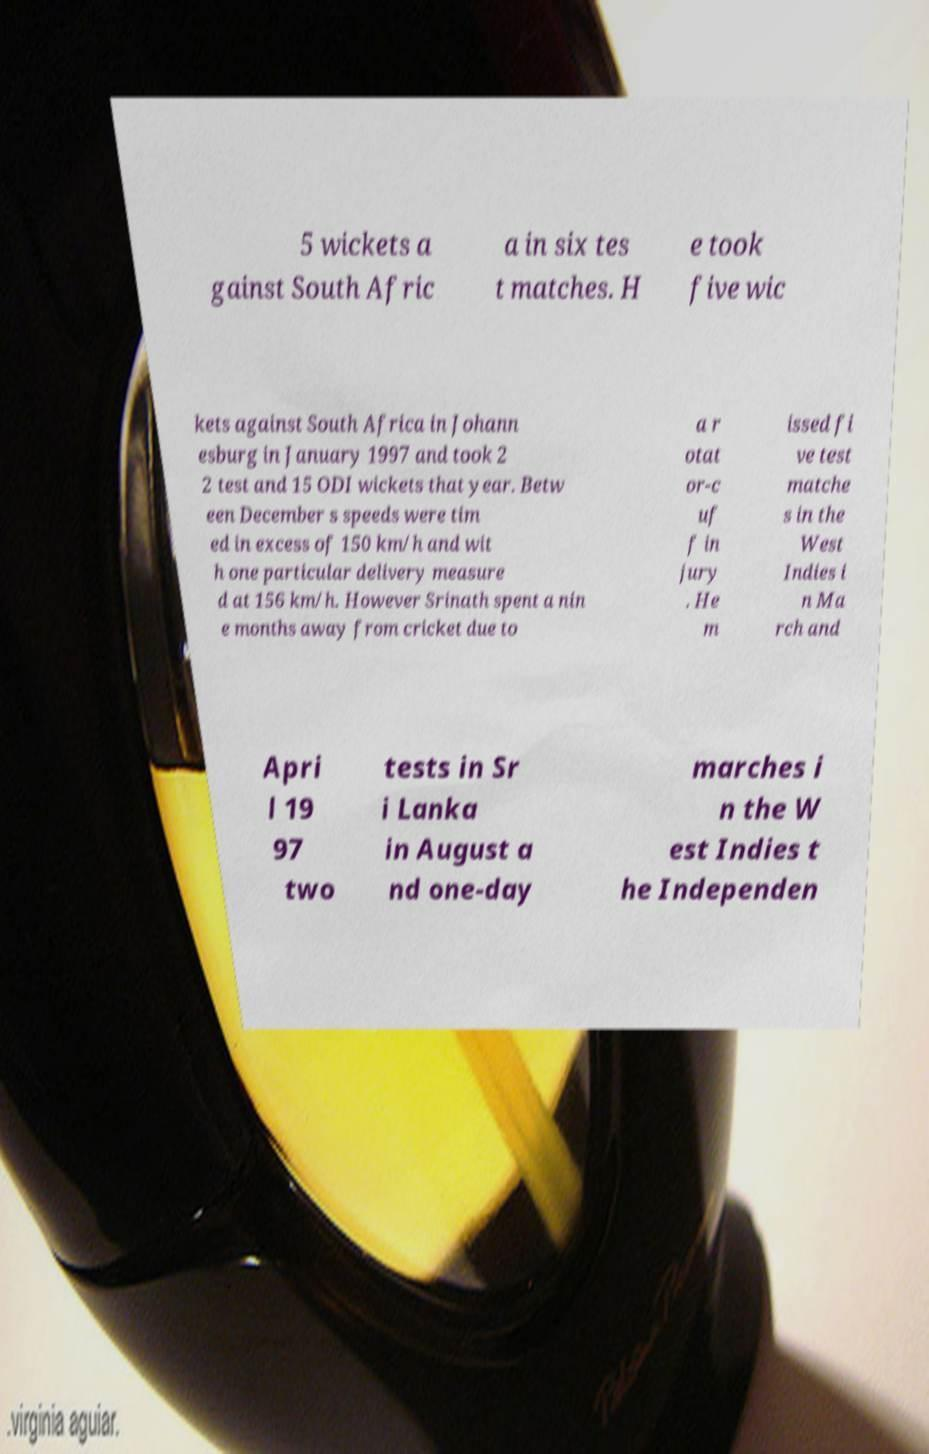There's text embedded in this image that I need extracted. Can you transcribe it verbatim? 5 wickets a gainst South Afric a in six tes t matches. H e took five wic kets against South Africa in Johann esburg in January 1997 and took 2 2 test and 15 ODI wickets that year. Betw een December s speeds were tim ed in excess of 150 km/h and wit h one particular delivery measure d at 156 km/h. However Srinath spent a nin e months away from cricket due to a r otat or-c uf f in jury . He m issed fi ve test matche s in the West Indies i n Ma rch and Apri l 19 97 two tests in Sr i Lanka in August a nd one-day marches i n the W est Indies t he Independen 